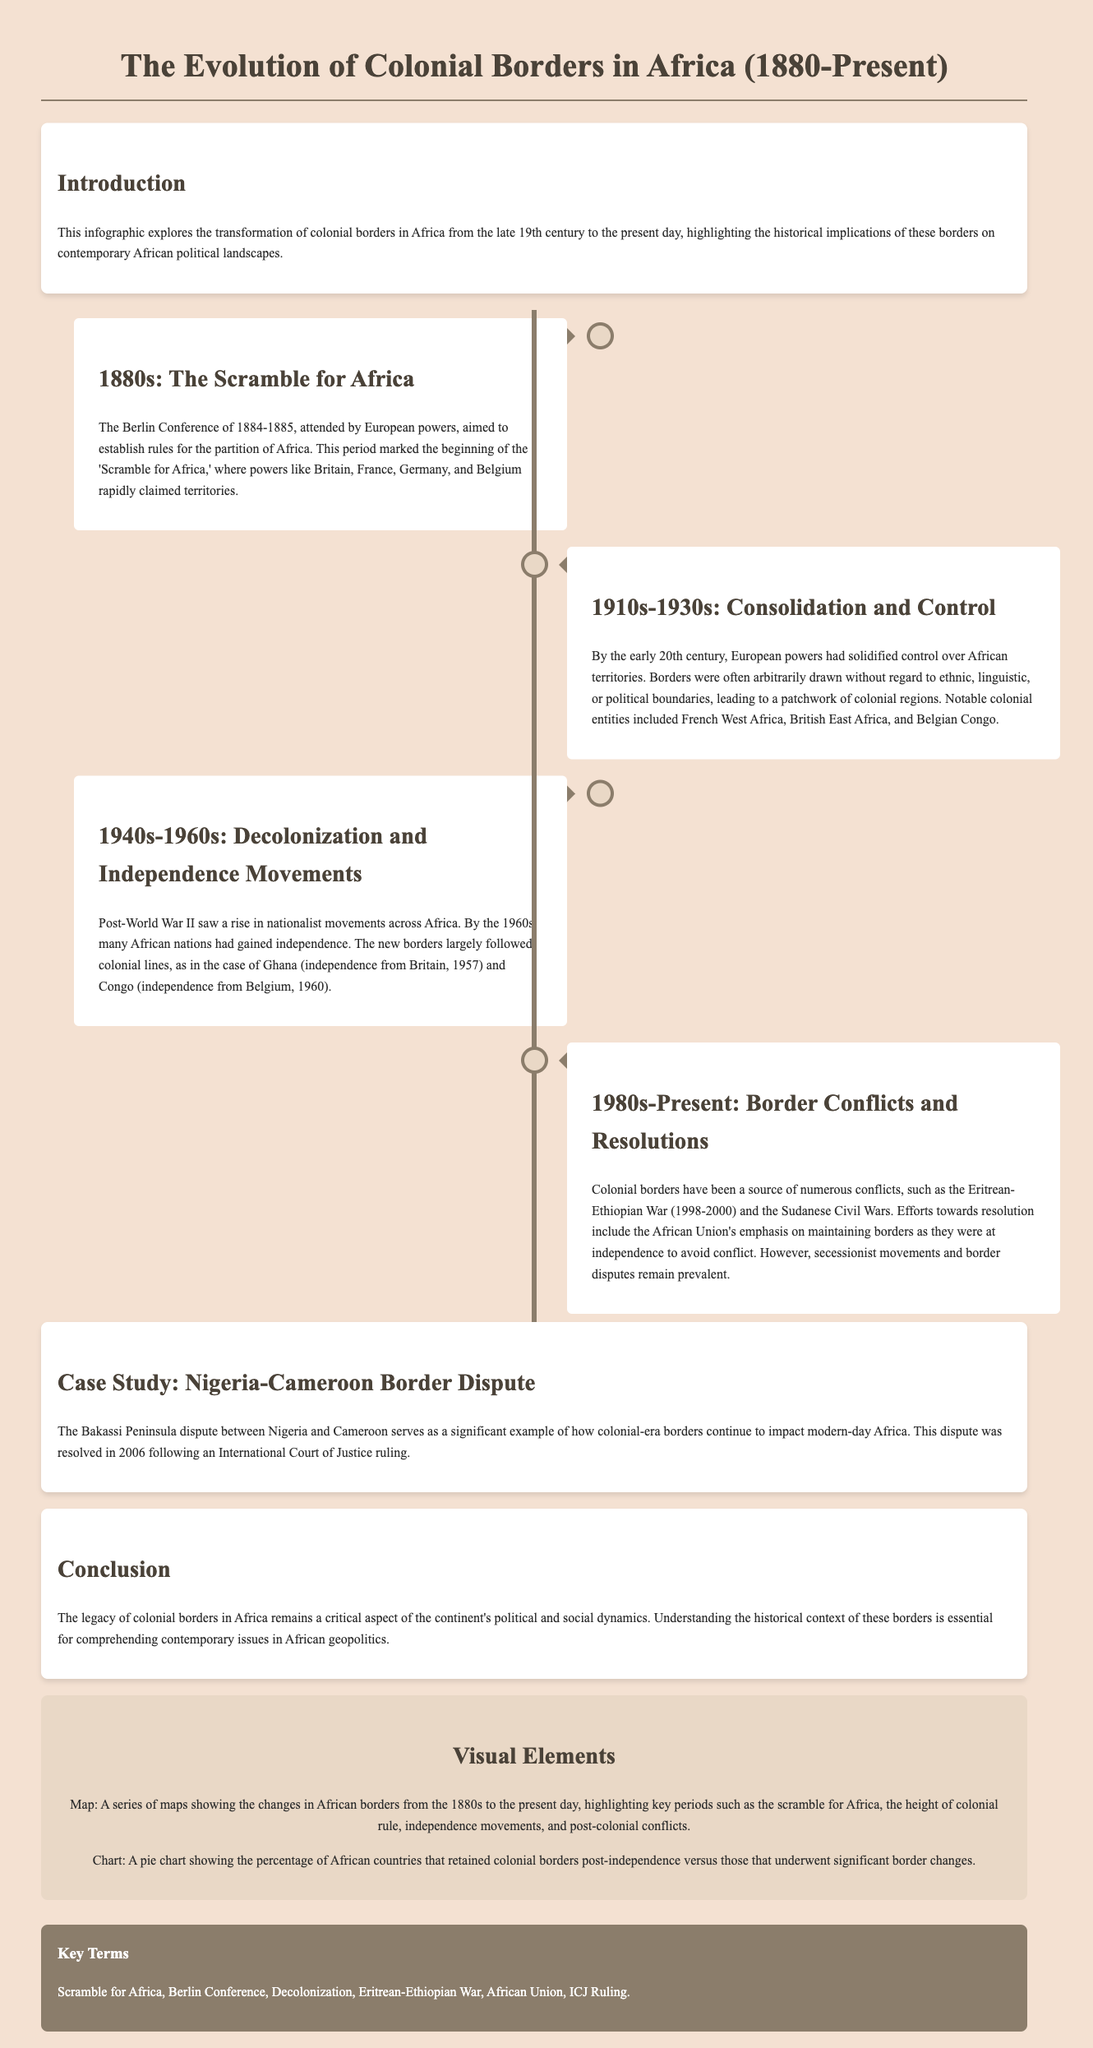What was the Berlin Conference? The Berlin Conference was a meeting of European powers aimed to establish rules for the partition of Africa during the 'Scramble for Africa.'
Answer: A meeting of European powers When did Ghana gain independence? Ghana gained independence from Britain in 1957.
Answer: 1957 Which conflict is highlighted as an example of issues arising from colonial borders? The infographic mentions the Eritrean-Ethiopian War as a conflict related to colonial borders.
Answer: Eritrean-Ethiopian War What is a key term associated with the colonial era in Africa? The infographic lists several key terms, including the 'Scramble for Africa.'
Answer: Scramble for Africa What significant dispute is discussed as a case study in the document? The Bakassi Peninsula dispute between Nigeria and Cameroon serves as a significant example of colonial border impacts.
Answer: Bakassi Peninsula dispute How did colonial borders impact post-independence nations, according to the document? The document notes that new borders largely followed colonial lines, impacting national identities.
Answer: Followed colonial lines What organization emphasizes maintaining borders as they were at independence? The African Union (AU) is mentioned as emphasizing the maintenance of colonial borders to avoid conflict.
Answer: African Union What period saw the rise of nationalist movements in Africa? The post-World War II period experienced a rise in nationalist movements leading to decolonization.
Answer: Post-World War II Which colonial entity existed in the early 20th century? Notable colonial entities included French West Africa.
Answer: French West Africa 